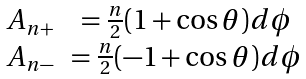Convert formula to latex. <formula><loc_0><loc_0><loc_500><loc_500>\begin{array} { c c } A _ { n + } & = \frac { n } { 2 } ( 1 + \cos \theta ) d \phi \\ A _ { n - } & = \frac { n } { 2 } ( - 1 + \cos \theta ) d \phi \end{array}</formula> 